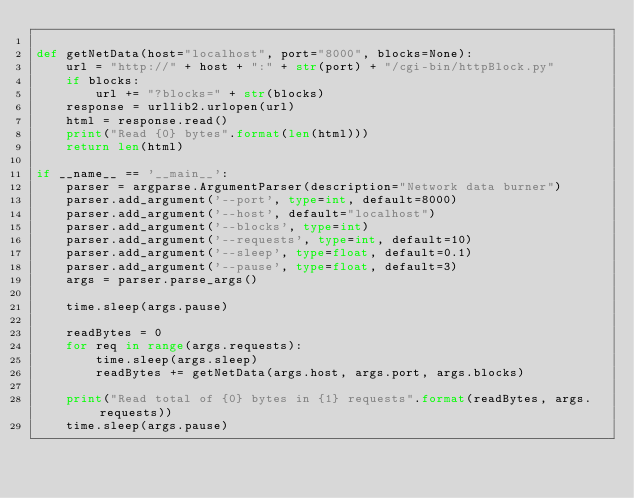Convert code to text. <code><loc_0><loc_0><loc_500><loc_500><_Python_>
def getNetData(host="localhost", port="8000", blocks=None):
    url = "http://" + host + ":" + str(port) + "/cgi-bin/httpBlock.py"
    if blocks:
        url += "?blocks=" + str(blocks)
    response = urllib2.urlopen(url)
    html = response.read()
    print("Read {0} bytes".format(len(html)))
    return len(html)

if __name__ == '__main__':
    parser = argparse.ArgumentParser(description="Network data burner")
    parser.add_argument('--port', type=int, default=8000)
    parser.add_argument('--host', default="localhost")
    parser.add_argument('--blocks', type=int)
    parser.add_argument('--requests', type=int, default=10)
    parser.add_argument('--sleep', type=float, default=0.1)
    parser.add_argument('--pause', type=float, default=3)
    args = parser.parse_args()
    
    time.sleep(args.pause)

    readBytes = 0
    for req in range(args.requests):
        time.sleep(args.sleep)
        readBytes += getNetData(args.host, args.port, args.blocks)
    
    print("Read total of {0} bytes in {1} requests".format(readBytes, args.requests))
    time.sleep(args.pause)
</code> 